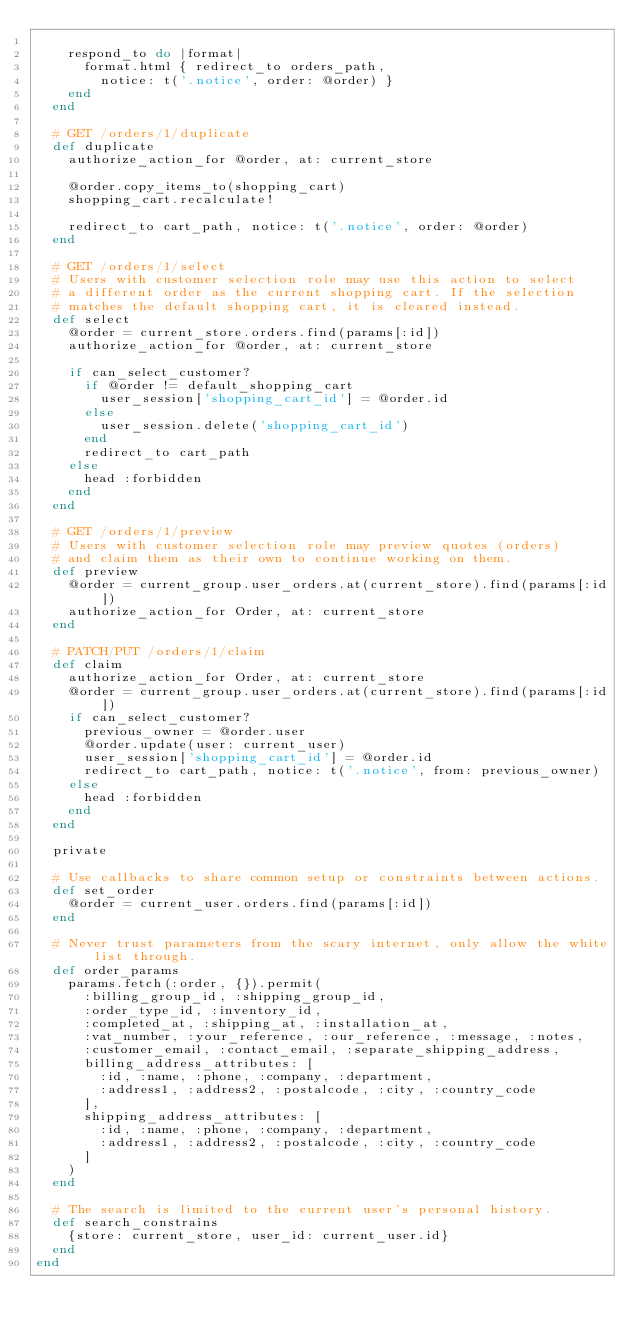Convert code to text. <code><loc_0><loc_0><loc_500><loc_500><_Ruby_>
    respond_to do |format|
      format.html { redirect_to orders_path,
        notice: t('.notice', order: @order) }
    end
  end

  # GET /orders/1/duplicate
  def duplicate
    authorize_action_for @order, at: current_store

    @order.copy_items_to(shopping_cart)
    shopping_cart.recalculate!

    redirect_to cart_path, notice: t('.notice', order: @order)
  end

  # GET /orders/1/select
  # Users with customer selection role may use this action to select
  # a different order as the current shopping cart. If the selection
  # matches the default shopping cart, it is cleared instead.
  def select
    @order = current_store.orders.find(params[:id])
    authorize_action_for @order, at: current_store

    if can_select_customer?
      if @order != default_shopping_cart
        user_session['shopping_cart_id'] = @order.id
      else
        user_session.delete('shopping_cart_id')
      end
      redirect_to cart_path
    else
      head :forbidden
    end
  end

  # GET /orders/1/preview
  # Users with customer selection role may preview quotes (orders)
  # and claim them as their own to continue working on them.
  def preview
    @order = current_group.user_orders.at(current_store).find(params[:id])
    authorize_action_for Order, at: current_store
  end

  # PATCH/PUT /orders/1/claim
  def claim
    authorize_action_for Order, at: current_store
    @order = current_group.user_orders.at(current_store).find(params[:id])
    if can_select_customer?
      previous_owner = @order.user
      @order.update(user: current_user)
      user_session['shopping_cart_id'] = @order.id
      redirect_to cart_path, notice: t('.notice', from: previous_owner)
    else
      head :forbidden
    end
  end

  private

  # Use callbacks to share common setup or constraints between actions.
  def set_order
    @order = current_user.orders.find(params[:id])
  end

  # Never trust parameters from the scary internet, only allow the white list through.
  def order_params
    params.fetch(:order, {}).permit(
      :billing_group_id, :shipping_group_id,
      :order_type_id, :inventory_id,
      :completed_at, :shipping_at, :installation_at,
      :vat_number, :your_reference, :our_reference, :message, :notes,
      :customer_email, :contact_email, :separate_shipping_address,
      billing_address_attributes: [
        :id, :name, :phone, :company, :department,
        :address1, :address2, :postalcode, :city, :country_code
      ],
      shipping_address_attributes: [
        :id, :name, :phone, :company, :department,
        :address1, :address2, :postalcode, :city, :country_code
      ]
    )
  end

  # The search is limited to the current user's personal history.
  def search_constrains
    {store: current_store, user_id: current_user.id}
  end
end
</code> 